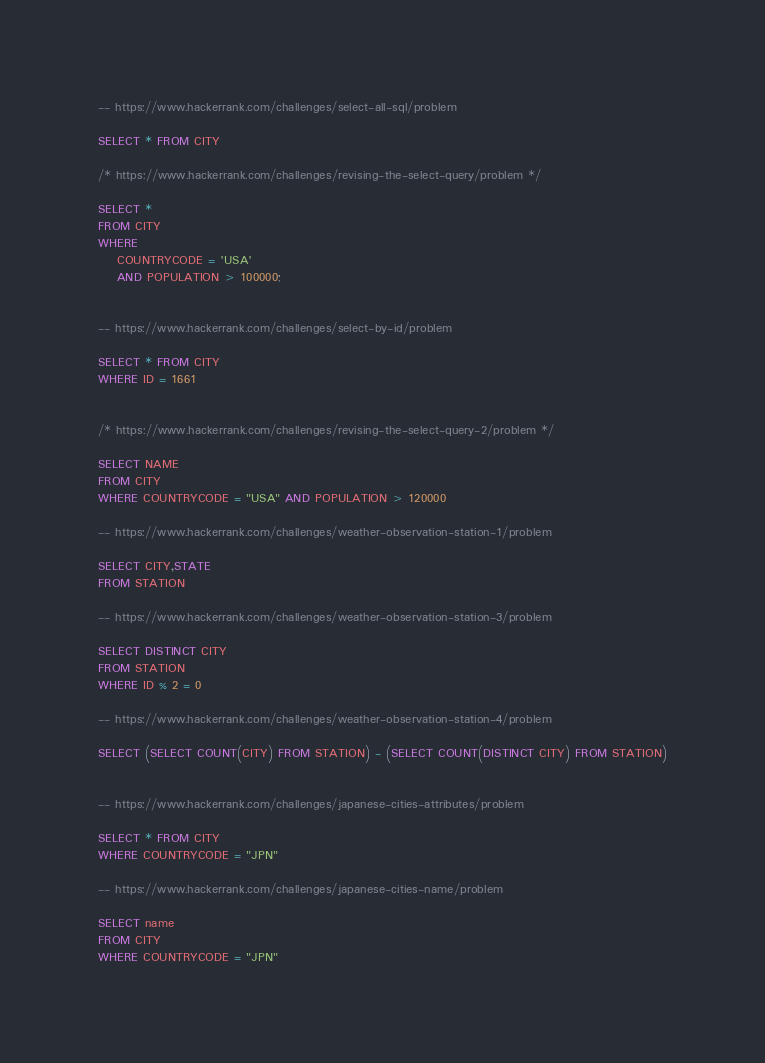Convert code to text. <code><loc_0><loc_0><loc_500><loc_500><_SQL_>-- https://www.hackerrank.com/challenges/select-all-sql/problem

SELECT * FROM CITY

/* https://www.hackerrank.com/challenges/revising-the-select-query/problem */

SELECT *
FROM CITY
WHERE
    COUNTRYCODE = 'USA'
    AND POPULATION > 100000;


-- https://www.hackerrank.com/challenges/select-by-id/problem

SELECT * FROM CITY
WHERE ID = 1661


/* https://www.hackerrank.com/challenges/revising-the-select-query-2/problem */

SELECT NAME 
FROM CITY
WHERE COUNTRYCODE = "USA" AND POPULATION > 120000

-- https://www.hackerrank.com/challenges/weather-observation-station-1/problem

SELECT CITY,STATE
FROM STATION

-- https://www.hackerrank.com/challenges/weather-observation-station-3/problem

SELECT DISTINCT CITY
FROM STATION 
WHERE ID % 2 = 0

-- https://www.hackerrank.com/challenges/weather-observation-station-4/problem

SELECT (SELECT COUNT(CITY) FROM STATION) - (SELECT COUNT(DISTINCT CITY) FROM STATION)


-- https://www.hackerrank.com/challenges/japanese-cities-attributes/problem

SELECT * FROM CITY
WHERE COUNTRYCODE = "JPN"

-- https://www.hackerrank.com/challenges/japanese-cities-name/problem

SELECT name
FROM CITY
WHERE COUNTRYCODE = "JPN"

</code> 